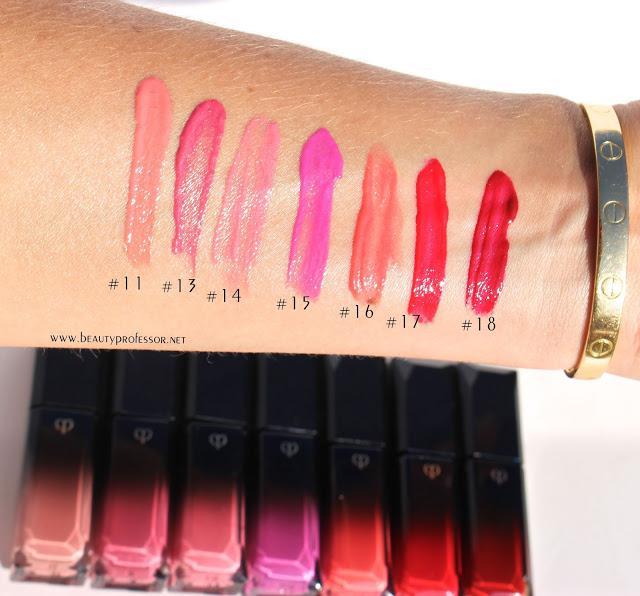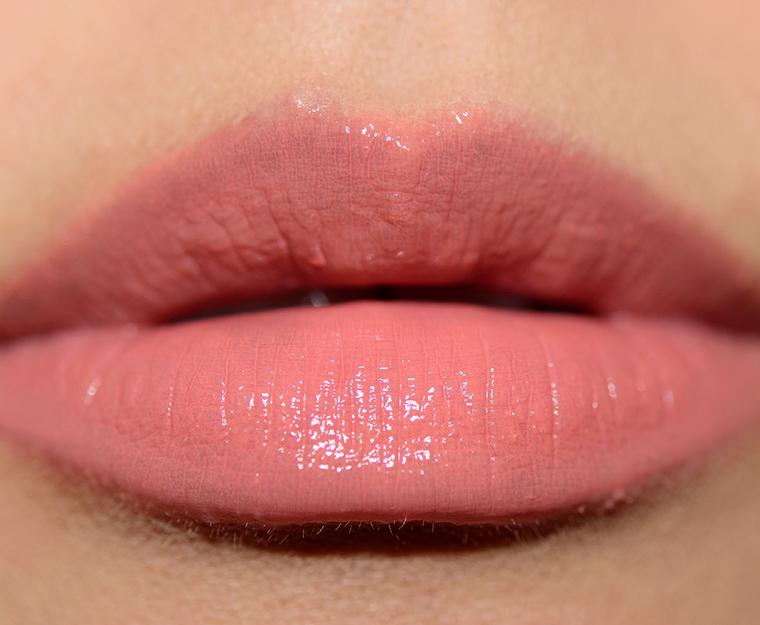The first image is the image on the left, the second image is the image on the right. Given the left and right images, does the statement "One photo is a closeup of tinted lips." hold true? Answer yes or no. Yes. 